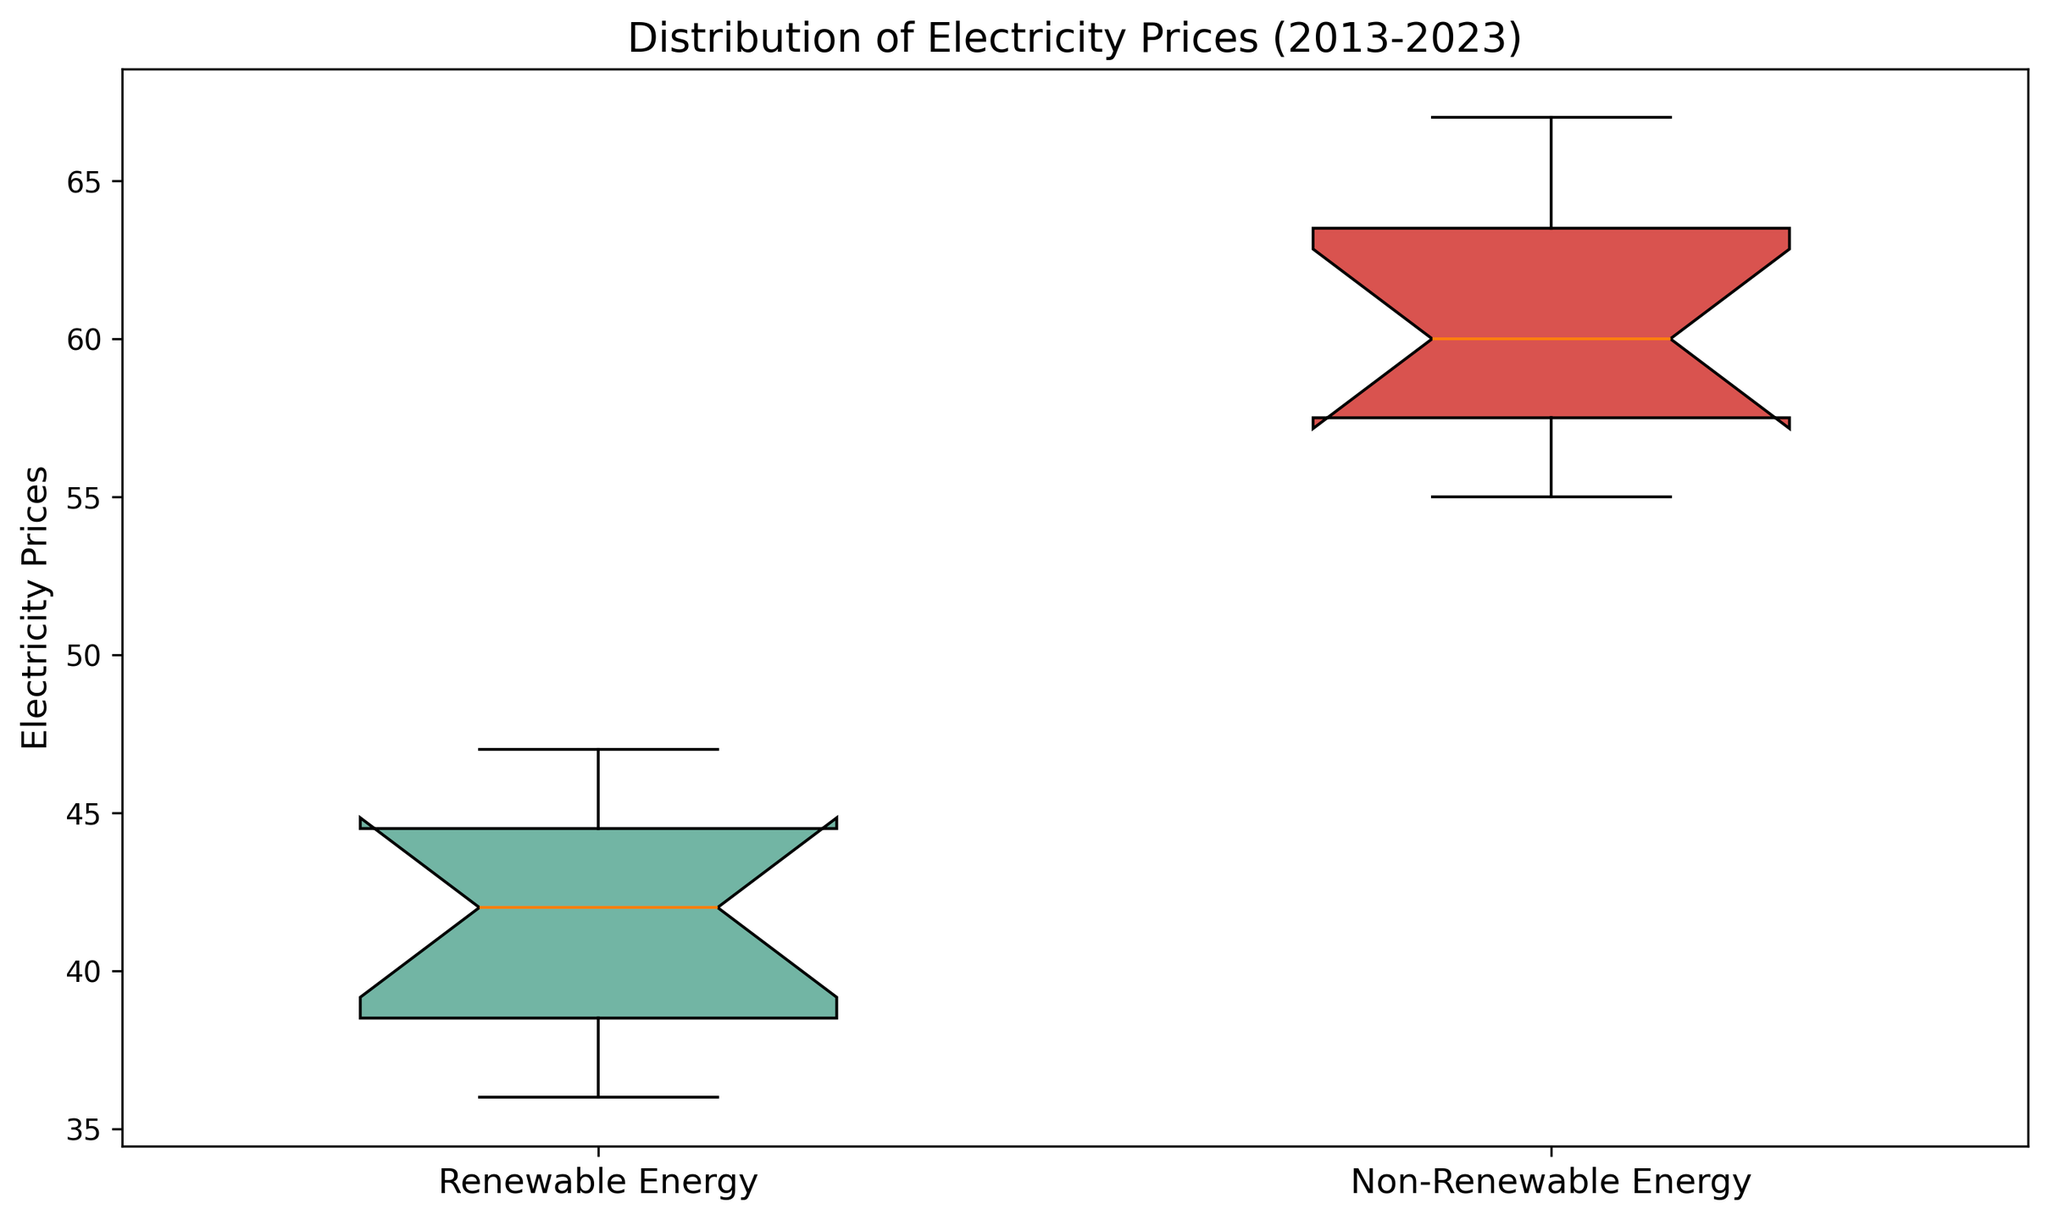Which energy type has a lower median electricity price? Observe the central line (median) within each box. The median for Renewable Energy is lower than Non-Renewable Energy.
Answer: Renewable Energy Which energy type shows less variability in electricity prices? Comparatively, the box for Renewable Energy is shorter in height, indicating less variability than the taller box for Non-Renewable Energy.
Answer: Renewable Energy Is the interquartile range (IQR) for renewable energy prices smaller or larger than for non-renewable energy prices? The height of the box represents the IQR. The box for Renewable Energy is shorter, indicating a smaller IQR compared to the taller box of Non-Renewable Energy.
Answer: Smaller Are there any outliers visible for renewable energy prices? Check for data points represented by individual markers outside the whiskers of the box. For Renewable Energy, no outliers are visible.
Answer: No What can you infer about the overall price trend from 2013 to 2023 for renewable and non-renewable energy sources? Overall, the central tendency (median) and spread (IQR) for Renewable Energy is lower than for Non-Renewable Energy, indicating that Renewable Energy has generally been cheaper.
Answer: Renewable Energy cheaper How does the range of electricity prices for non-renewable energy compare to renewable energy? The range is the difference between the highest and lowest values. The distance between the upper and lower whiskers is longer for Non-Renewable Energy, indicating a wider range.
Answer: Wider What is the relative position of the minimum price for renewable energy compared to the median of non-renewable energy? The bottom whisker of Renewable Energy doesn't reach the median line of Non-Renewable Energy, indicating the minimum price for Renewable Energy is lower than the median for Non-Renewable Energy.
Answer: Lower What does the position of the median within each box signify about the skewness of the data for each energy type? A median closer to the bottom indicates a negatively skewed distribution, while a median closer to the top signifies positive skewness. The medians in both boxes do not show significant skewness indicators.
Answer: No significant skewness How do the maximum electricity prices for renewable and non-renewable energy sources compare? The top whisker represents the maximum value. The top whisker for Non-Renewable Energy is higher than for Renewable Energy.
Answer: Non-Renewable Energy 